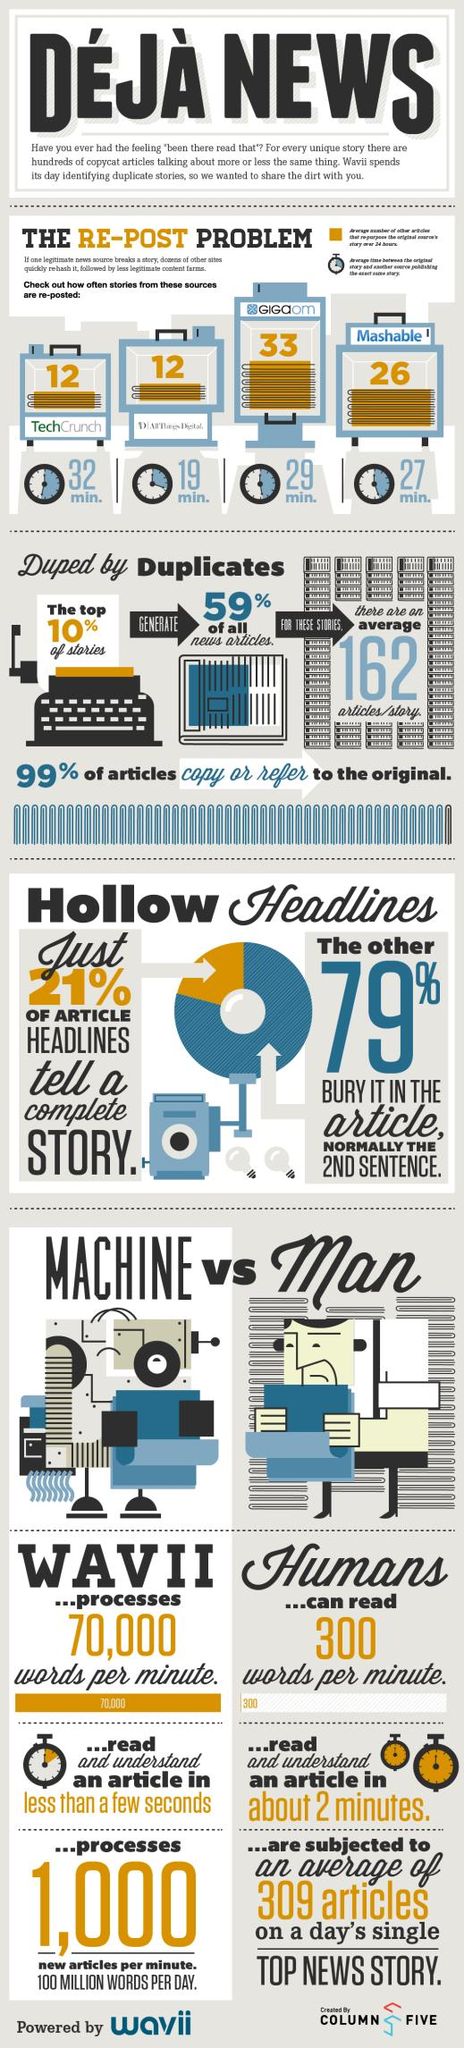Indicate a few pertinent items in this graphic. Machines can read approximately 70,000 words per minute. 